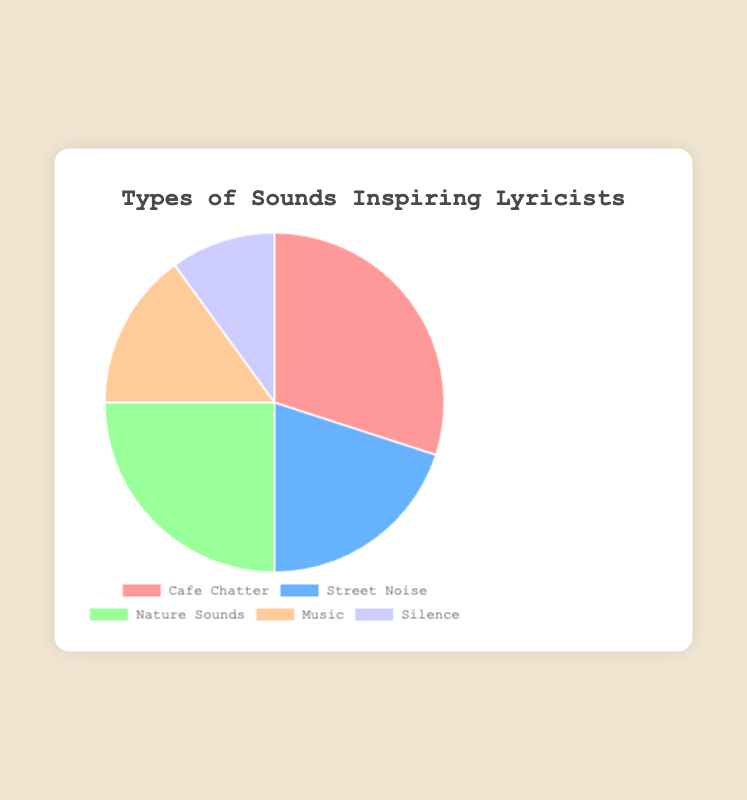What percentage of lyricists are inspired by Nature Sounds? According to the pie chart, Nature Sounds inspire 25% of lyricists.
Answer: 25% Which type of sound inspires the most lyricists? The pie chart shows that Cafe Chatter, with 30%, is the most inspiring sound for lyricists.
Answer: Cafe Chatter How much more popular is Cafe Chatter compared to Silence among lyricists? Cafe Chatter inspires 30% of lyricists, while Silence inspires 10%. The difference is 30% - 10% = 20%.
Answer: 20% What is the second most popular type of sound that inspires lyricists? Nature Sounds, inspiring 25% of lyricists, is the second most popular after Cafe Chatter.
Answer: Nature Sounds Which two types of sounds together make up exactly half of the inspiration sources for lyricists? Cafe Chatter and Street Noise together form 30% + 20% = 50%, which is exactly half.
Answer: Cafe Chatter and Street Noise What is the least popular type of sound among lyricists? Silence, inspiring 10% of lyricists, is the least popular.
Answer: Silence How many types of sounds inspire more than 20% of lyricists each? Two types, Cafe Chatter (30%) and Nature Sounds (25%), inspire more than 20% of lyricists each.
Answer: 2 Which type of sound has a percentage closest to 20%? Street Noise, with 20%, is the type of sound closest to 20%.
Answer: Street Noise Which color represents the inspiration from Music according to the pie chart? The segment representing Music is colored light orange.
Answer: Light orange What is the combined percentage of lyricists inspired by Street Noise and Music? Street Noise inspires 20% and Music 15%, combining to 20% + 15% = 35%.
Answer: 35% 